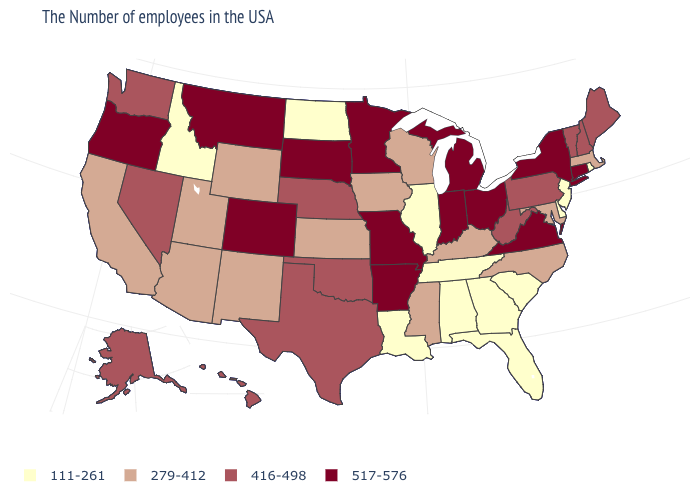What is the value of New Hampshire?
Keep it brief. 416-498. How many symbols are there in the legend?
Write a very short answer. 4. What is the value of Alaska?
Be succinct. 416-498. How many symbols are there in the legend?
Short answer required. 4. Which states have the lowest value in the West?
Be succinct. Idaho. What is the highest value in states that border Nebraska?
Short answer required. 517-576. What is the value of Pennsylvania?
Short answer required. 416-498. Is the legend a continuous bar?
Short answer required. No. Which states hav the highest value in the Northeast?
Give a very brief answer. Connecticut, New York. Which states hav the highest value in the MidWest?
Short answer required. Ohio, Michigan, Indiana, Missouri, Minnesota, South Dakota. What is the highest value in states that border Wyoming?
Write a very short answer. 517-576. What is the highest value in the Northeast ?
Write a very short answer. 517-576. Name the states that have a value in the range 111-261?
Answer briefly. Rhode Island, New Jersey, Delaware, South Carolina, Florida, Georgia, Alabama, Tennessee, Illinois, Louisiana, North Dakota, Idaho. What is the value of Arizona?
Be succinct. 279-412. 